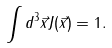<formula> <loc_0><loc_0><loc_500><loc_500>\int d ^ { 3 } \vec { x } J ( \vec { x } ) = 1 .</formula> 